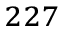<formula> <loc_0><loc_0><loc_500><loc_500>^ { 2 2 7 }</formula> 